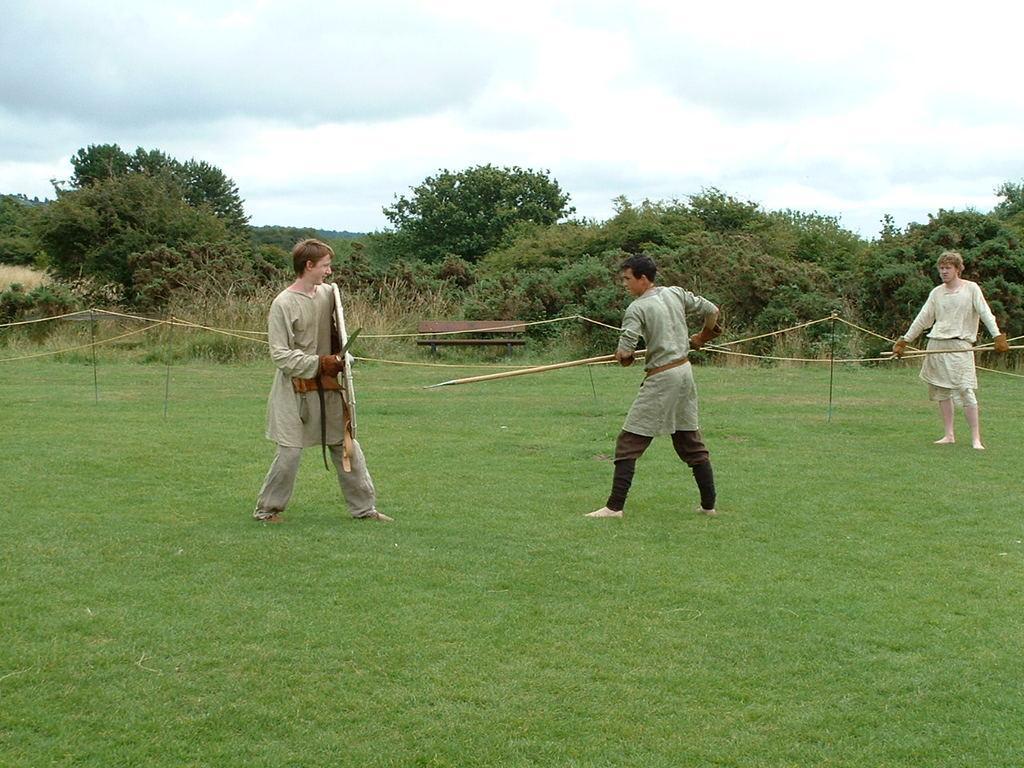How would you summarize this image in a sentence or two? In this picture I can see green grass. I can see people holding weapons. I can see trees. I can see clouds in the sky. 